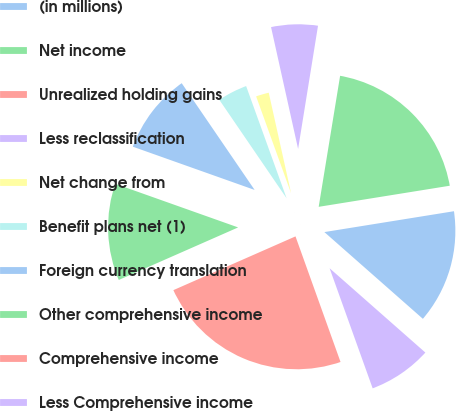Convert chart to OTSL. <chart><loc_0><loc_0><loc_500><loc_500><pie_chart><fcel>(in millions)<fcel>Net income<fcel>Unrealized holding gains<fcel>Less reclassification<fcel>Net change from<fcel>Benefit plans net (1)<fcel>Foreign currency translation<fcel>Other comprehensive income<fcel>Comprehensive income<fcel>Less Comprehensive income<nl><fcel>14.03%<fcel>19.88%<fcel>0.03%<fcel>6.03%<fcel>2.03%<fcel>4.03%<fcel>10.03%<fcel>12.03%<fcel>23.88%<fcel>8.03%<nl></chart> 